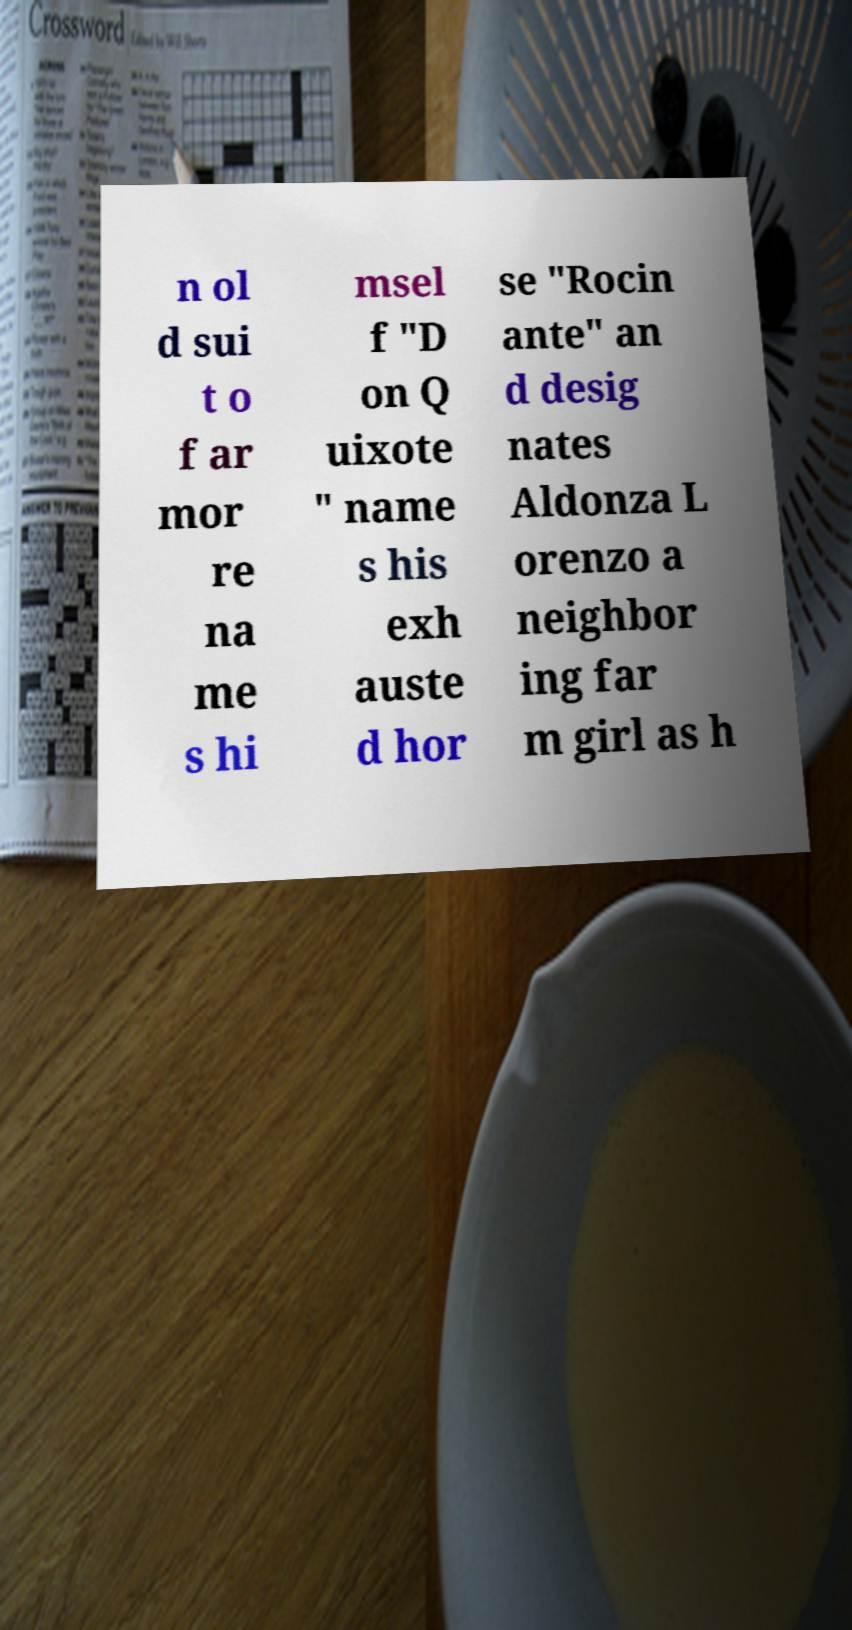Please identify and transcribe the text found in this image. n ol d sui t o f ar mor re na me s hi msel f "D on Q uixote " name s his exh auste d hor se "Rocin ante" an d desig nates Aldonza L orenzo a neighbor ing far m girl as h 